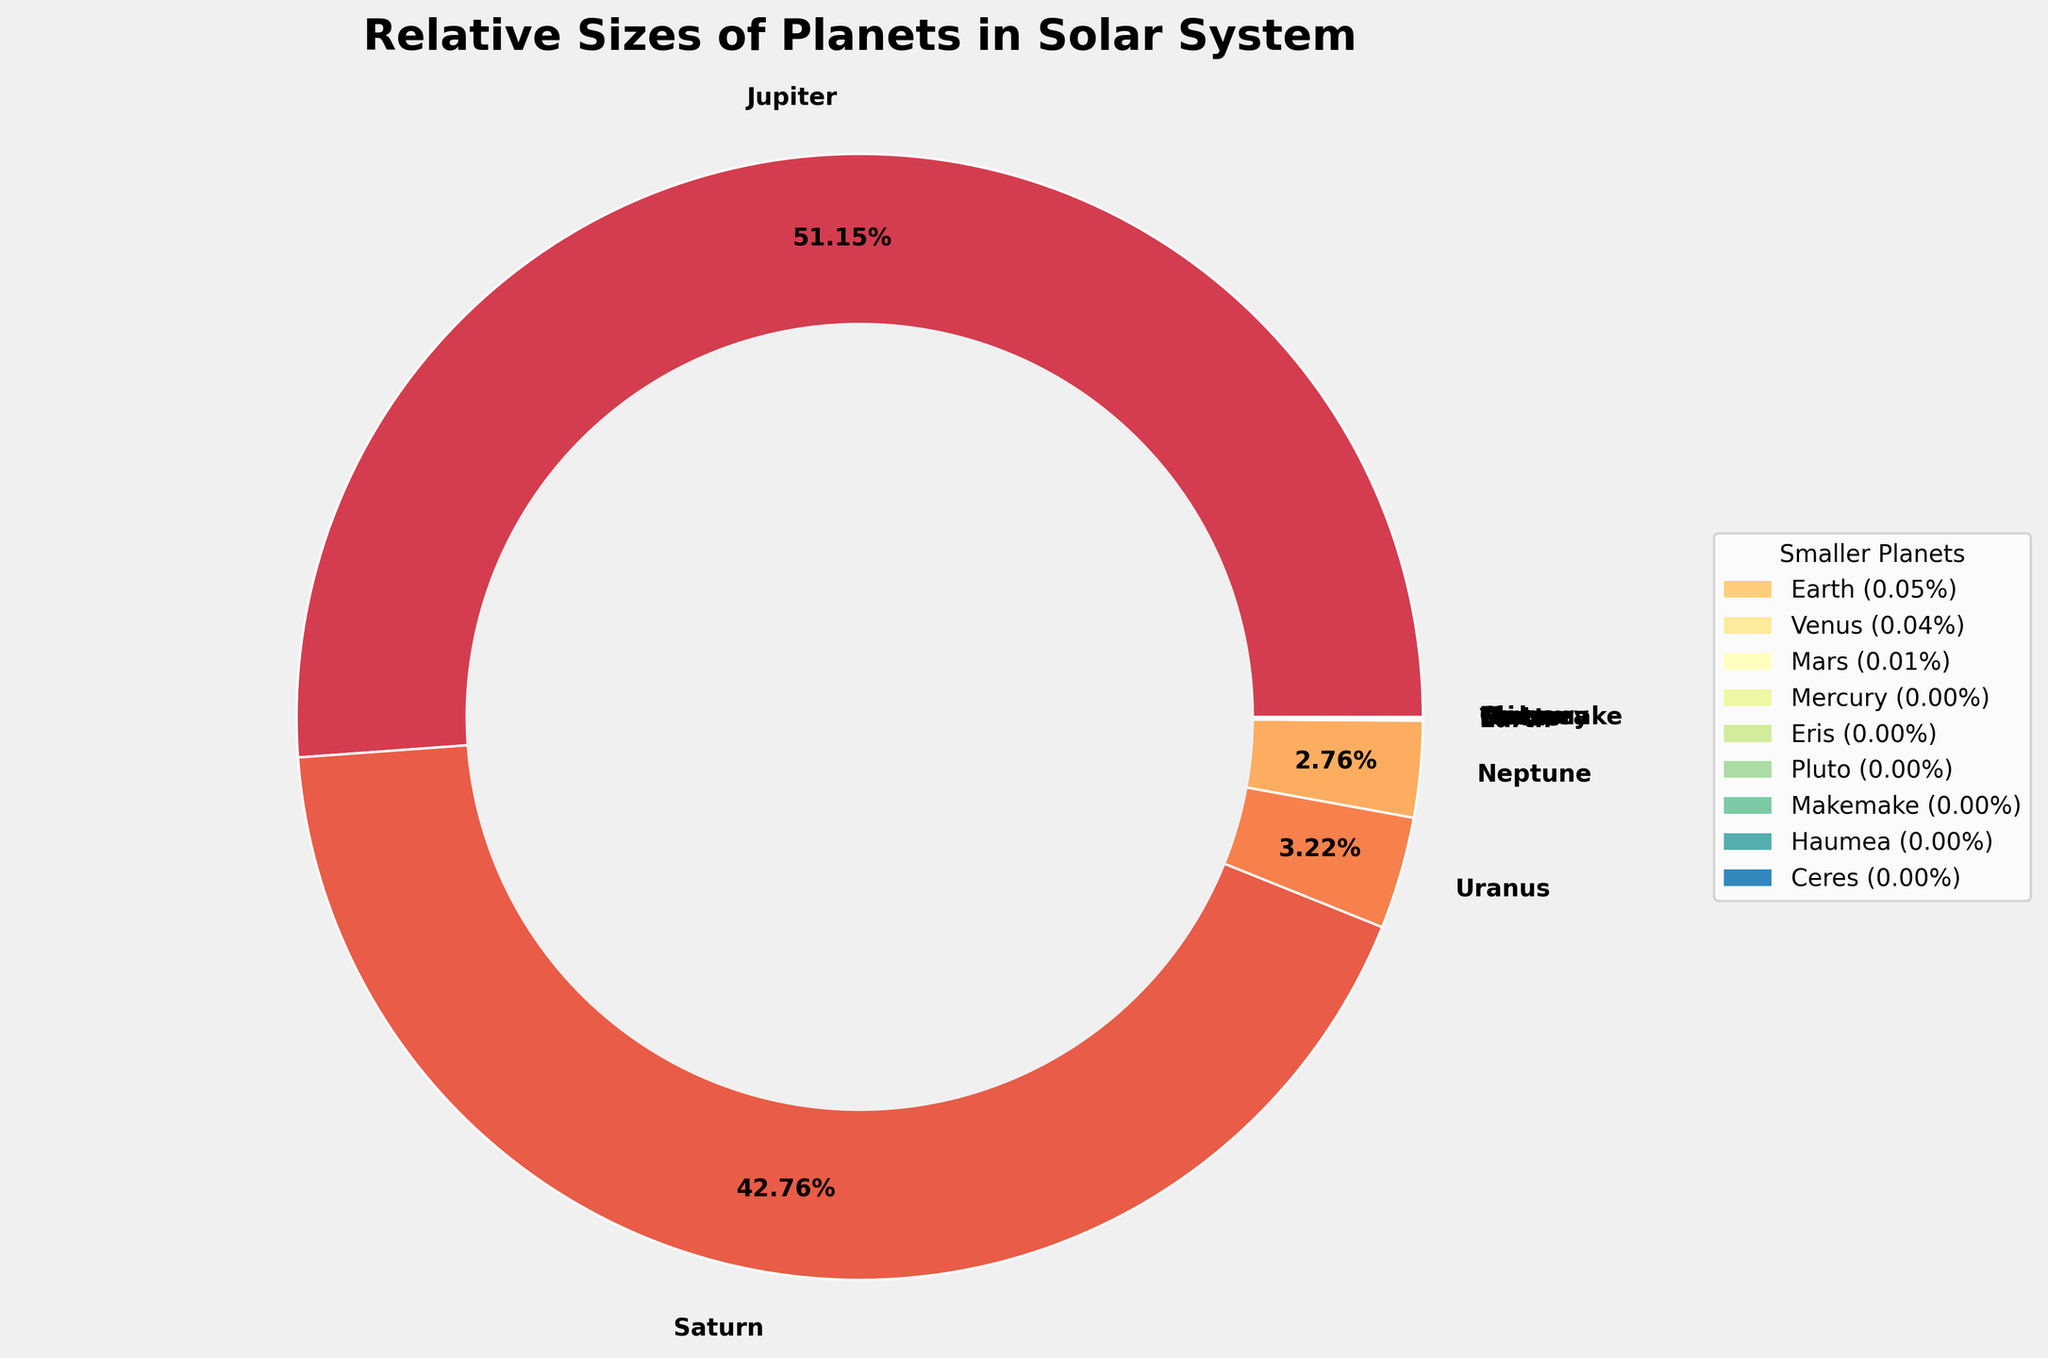Which planet has the largest relative size? Jupiter is labeled with the largest percentage in the pie chart, indicating it has the largest relative size.
Answer: Jupiter Which two dwarf planets have the smallest relative sizes? The legend for smaller planets shows Haumea and Ceres with the smallest percentages.
Answer: Haumea and Ceres What percentage of the total relative size is contributed by Earth? Earth is labeled within the pie chart, showing its percentage directly as 0.10%.
Answer: 0.10% How does the relative size of Saturn compare to Uranus? Saturn is significantly larger; Saturn's segment in the pie chart is much larger than Uranus's, and Saturn's percentage is 12.11 times that of Uranus (836 compared to 63).
Answer: Saturn is much larger What is the combined relative size of Mars and Mercury? Mars is labeled 0.15%, and Mercury is 0.06%, so the combined relative size is 0.15% + 0.06% = 0.21%.
Answer: 0.21% Which planet's segment comes immediately after Earth in the pie chart? Venus directly follows Earth in the pie chart, having a similar but slightly smaller size.
Answer: Venus What percentage of the total relative size do Jupiter and Saturn combined represent? Jupiter is 1000, and Saturn is 836. Combined, they are 1836 out of the total sum. Calculation: (1836 / (sum of all sizes)) * 100%. The exact sum is 1000 + 836 + 63 + 54 + 1 + 0.86 + 0.15 + 0.06 + 0.0022 + 0.0028 + 0.0007 + 0.0007 + 0.0002 = 1956.022. So, (1836 / 1956.022) * 100% = 93.86%.
Answer: 93.86% Which dwarf planet is relatively larger, Pluto or Eris? Eris is slightly larger than Pluto as indicated by the pie chart percentages and segments.
Answer: Eris How many planets/dwarf planets contribute less than 1% each to the total size? By counting the smaller percentages in the legend and the pie chart, there are 7 planets (Earth, Venus, Mars, Mercury, Pluto, Eris, Haumea, Makemake, and Ceres) that are each less than 1%.
Answer: 7 What is the visual difference between the largest and smallest planet segments? The segment for Jupiter is the largest, prominently displayed with a wide arc, whereas the smallest segments for Haumea and Ceres are almost imperceptible.
Answer: Jupiter's segment is the largest, while Haumea and Ceres are the smallest 